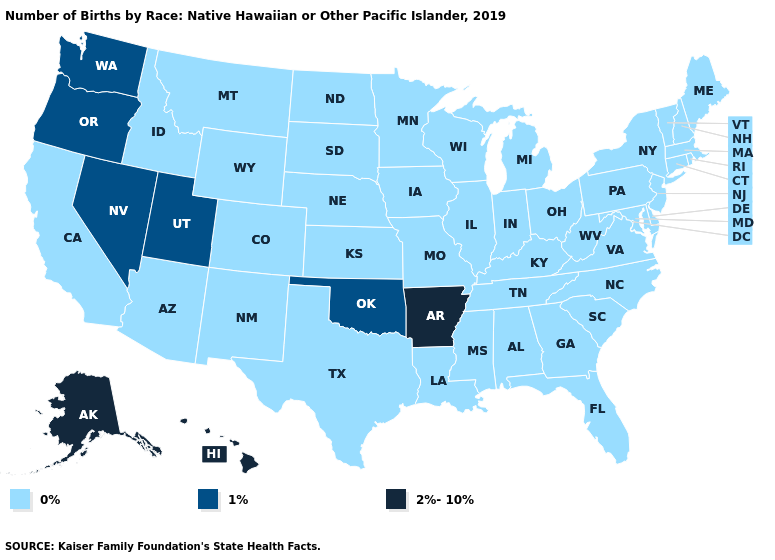What is the highest value in states that border Wisconsin?
Concise answer only. 0%. Name the states that have a value in the range 1%?
Write a very short answer. Nevada, Oklahoma, Oregon, Utah, Washington. Does Wyoming have the lowest value in the West?
Write a very short answer. Yes. What is the value of Texas?
Concise answer only. 0%. Among the states that border Arizona , which have the highest value?
Short answer required. Nevada, Utah. What is the value of Illinois?
Quick response, please. 0%. Does Hawaii have the highest value in the USA?
Answer briefly. Yes. Name the states that have a value in the range 1%?
Quick response, please. Nevada, Oklahoma, Oregon, Utah, Washington. What is the value of Alaska?
Quick response, please. 2%-10%. Does the first symbol in the legend represent the smallest category?
Short answer required. Yes. Does the first symbol in the legend represent the smallest category?
Write a very short answer. Yes. Which states have the lowest value in the USA?
Quick response, please. Alabama, Arizona, California, Colorado, Connecticut, Delaware, Florida, Georgia, Idaho, Illinois, Indiana, Iowa, Kansas, Kentucky, Louisiana, Maine, Maryland, Massachusetts, Michigan, Minnesota, Mississippi, Missouri, Montana, Nebraska, New Hampshire, New Jersey, New Mexico, New York, North Carolina, North Dakota, Ohio, Pennsylvania, Rhode Island, South Carolina, South Dakota, Tennessee, Texas, Vermont, Virginia, West Virginia, Wisconsin, Wyoming. Is the legend a continuous bar?
Give a very brief answer. No. What is the highest value in states that border Massachusetts?
Short answer required. 0%. What is the value of Maryland?
Short answer required. 0%. 